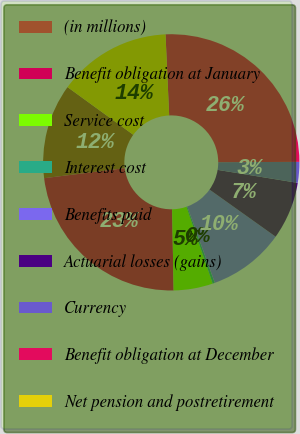<chart> <loc_0><loc_0><loc_500><loc_500><pie_chart><fcel>(in millions)<fcel>Benefit obligation at January<fcel>Service cost<fcel>Interest cost<fcel>Benefits paid<fcel>Actuarial losses (gains)<fcel>Currency<fcel>Benefit obligation at December<fcel>Net pension and postretirement<nl><fcel>11.96%<fcel>23.32%<fcel>4.95%<fcel>0.28%<fcel>9.63%<fcel>7.29%<fcel>2.62%<fcel>25.66%<fcel>14.3%<nl></chart> 